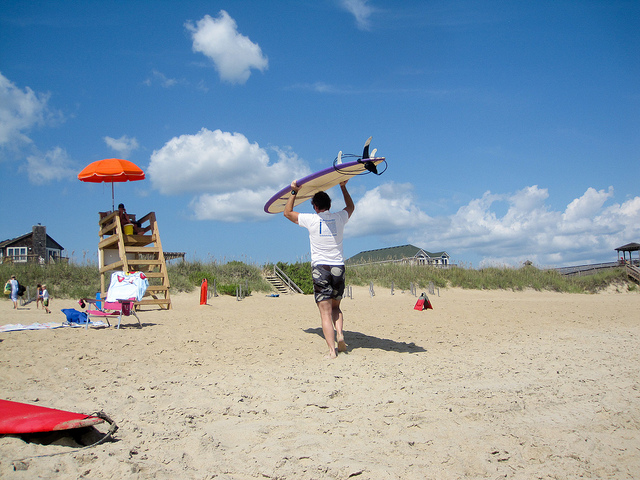How many surfboards can you see? 2 